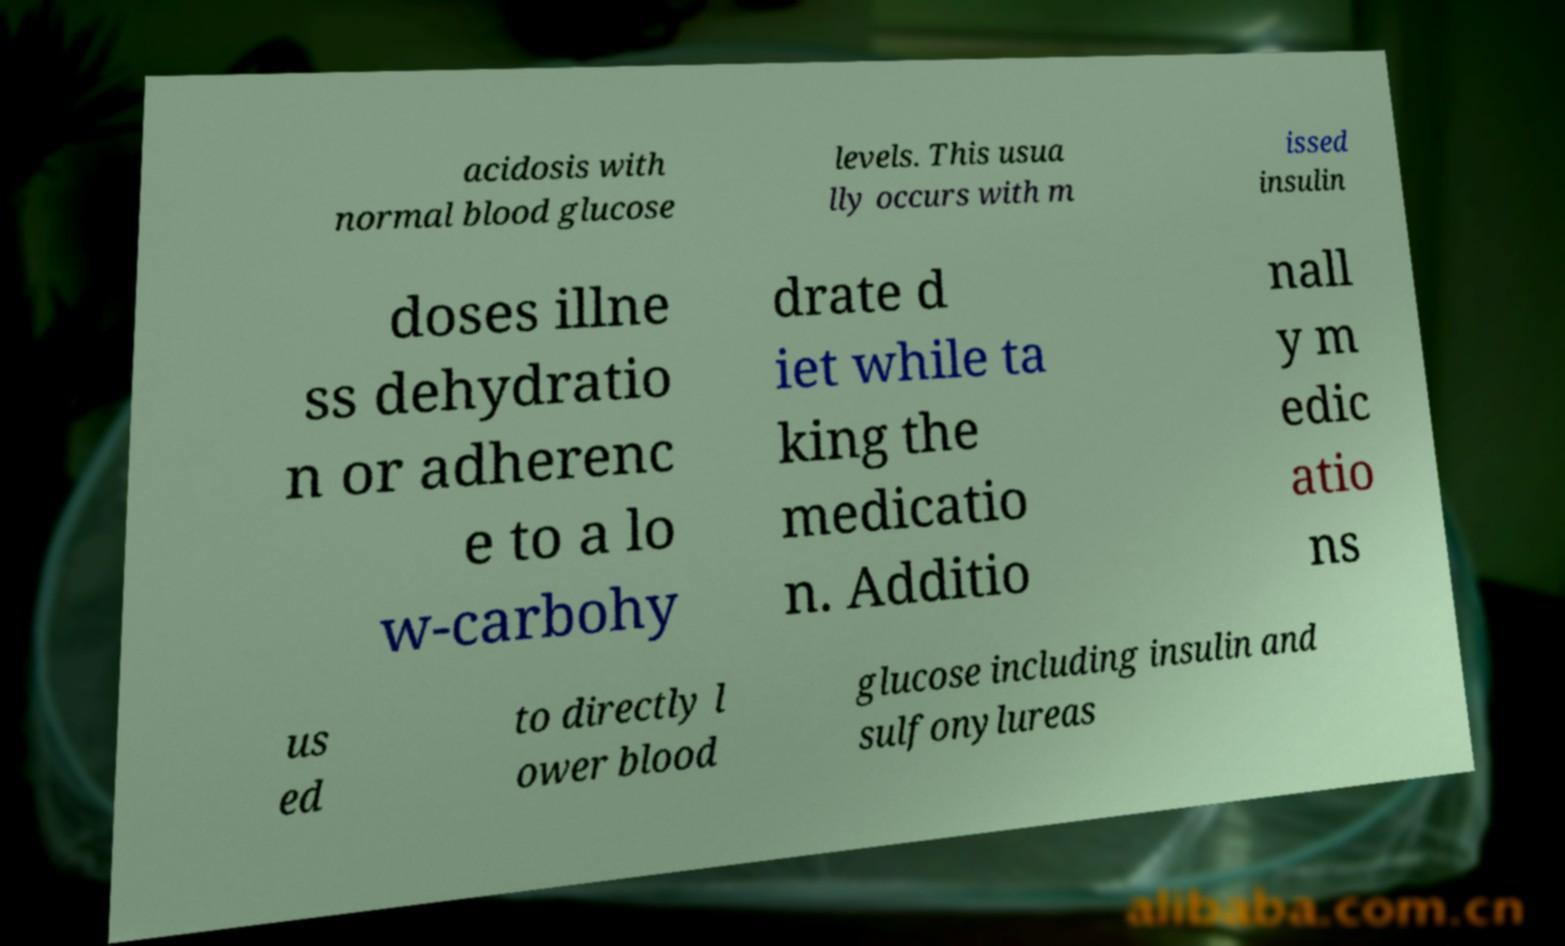I need the written content from this picture converted into text. Can you do that? acidosis with normal blood glucose levels. This usua lly occurs with m issed insulin doses illne ss dehydratio n or adherenc e to a lo w-carbohy drate d iet while ta king the medicatio n. Additio nall y m edic atio ns us ed to directly l ower blood glucose including insulin and sulfonylureas 